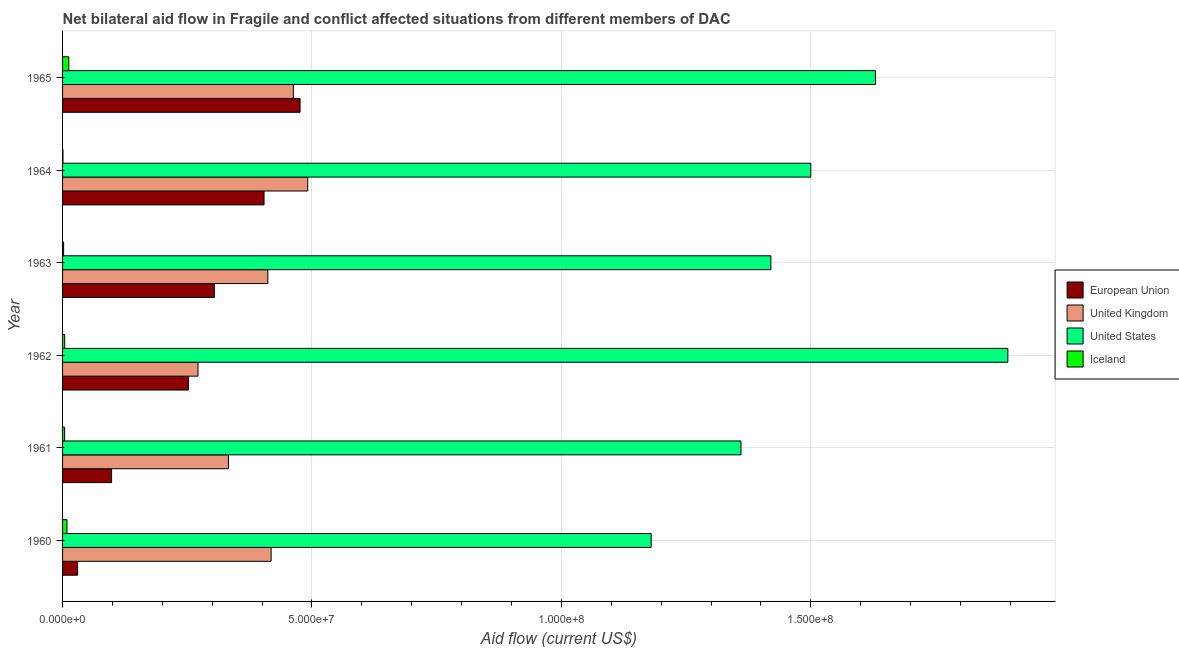Are the number of bars per tick equal to the number of legend labels?
Ensure brevity in your answer.  Yes. How many bars are there on the 1st tick from the bottom?
Offer a very short reply. 4. What is the label of the 5th group of bars from the top?
Give a very brief answer. 1961. What is the amount of aid given by us in 1962?
Offer a terse response. 1.90e+08. Across all years, what is the maximum amount of aid given by us?
Provide a short and direct response. 1.90e+08. Across all years, what is the minimum amount of aid given by iceland?
Provide a short and direct response. 8.00e+04. In which year was the amount of aid given by iceland maximum?
Provide a short and direct response. 1965. In which year was the amount of aid given by iceland minimum?
Provide a succinct answer. 1964. What is the total amount of aid given by us in the graph?
Your response must be concise. 8.98e+08. What is the difference between the amount of aid given by uk in 1963 and that in 1965?
Your answer should be compact. -5.11e+06. What is the difference between the amount of aid given by iceland in 1964 and the amount of aid given by us in 1960?
Your answer should be compact. -1.18e+08. What is the average amount of aid given by eu per year?
Your answer should be compact. 2.61e+07. In the year 1960, what is the difference between the amount of aid given by uk and amount of aid given by eu?
Give a very brief answer. 3.88e+07. In how many years, is the amount of aid given by uk greater than 20000000 US$?
Your answer should be compact. 6. What is the ratio of the amount of aid given by iceland in 1961 to that in 1964?
Give a very brief answer. 5.25. Is the amount of aid given by iceland in 1961 less than that in 1964?
Provide a succinct answer. No. Is the difference between the amount of aid given by eu in 1962 and 1964 greater than the difference between the amount of aid given by iceland in 1962 and 1964?
Ensure brevity in your answer.  No. What is the difference between the highest and the second highest amount of aid given by iceland?
Your answer should be compact. 3.70e+05. What is the difference between the highest and the lowest amount of aid given by uk?
Offer a terse response. 2.20e+07. Is the sum of the amount of aid given by uk in 1961 and 1965 greater than the maximum amount of aid given by eu across all years?
Provide a short and direct response. Yes. What does the 1st bar from the bottom in 1963 represents?
Give a very brief answer. European Union. How many bars are there?
Your answer should be compact. 24. How many years are there in the graph?
Keep it short and to the point. 6. What is the difference between two consecutive major ticks on the X-axis?
Ensure brevity in your answer.  5.00e+07. Are the values on the major ticks of X-axis written in scientific E-notation?
Provide a short and direct response. Yes. How many legend labels are there?
Keep it short and to the point. 4. How are the legend labels stacked?
Keep it short and to the point. Vertical. What is the title of the graph?
Your answer should be very brief. Net bilateral aid flow in Fragile and conflict affected situations from different members of DAC. What is the label or title of the X-axis?
Your response must be concise. Aid flow (current US$). What is the Aid flow (current US$) of European Union in 1960?
Provide a short and direct response. 3.02e+06. What is the Aid flow (current US$) of United Kingdom in 1960?
Provide a short and direct response. 4.18e+07. What is the Aid flow (current US$) in United States in 1960?
Offer a very short reply. 1.18e+08. What is the Aid flow (current US$) of Iceland in 1960?
Your answer should be very brief. 8.80e+05. What is the Aid flow (current US$) of European Union in 1961?
Your answer should be very brief. 9.83e+06. What is the Aid flow (current US$) in United Kingdom in 1961?
Your answer should be very brief. 3.33e+07. What is the Aid flow (current US$) of United States in 1961?
Make the answer very short. 1.36e+08. What is the Aid flow (current US$) of Iceland in 1961?
Your answer should be very brief. 4.20e+05. What is the Aid flow (current US$) in European Union in 1962?
Give a very brief answer. 2.52e+07. What is the Aid flow (current US$) of United Kingdom in 1962?
Offer a very short reply. 2.72e+07. What is the Aid flow (current US$) of United States in 1962?
Your response must be concise. 1.90e+08. What is the Aid flow (current US$) of Iceland in 1962?
Make the answer very short. 4.30e+05. What is the Aid flow (current US$) of European Union in 1963?
Your answer should be very brief. 3.04e+07. What is the Aid flow (current US$) of United Kingdom in 1963?
Provide a short and direct response. 4.12e+07. What is the Aid flow (current US$) in United States in 1963?
Your answer should be compact. 1.42e+08. What is the Aid flow (current US$) of European Union in 1964?
Give a very brief answer. 4.04e+07. What is the Aid flow (current US$) in United Kingdom in 1964?
Keep it short and to the point. 4.92e+07. What is the Aid flow (current US$) in United States in 1964?
Provide a succinct answer. 1.50e+08. What is the Aid flow (current US$) in European Union in 1965?
Your answer should be very brief. 4.76e+07. What is the Aid flow (current US$) of United Kingdom in 1965?
Your answer should be compact. 4.63e+07. What is the Aid flow (current US$) in United States in 1965?
Ensure brevity in your answer.  1.63e+08. What is the Aid flow (current US$) in Iceland in 1965?
Offer a very short reply. 1.25e+06. Across all years, what is the maximum Aid flow (current US$) of European Union?
Offer a very short reply. 4.76e+07. Across all years, what is the maximum Aid flow (current US$) of United Kingdom?
Your answer should be very brief. 4.92e+07. Across all years, what is the maximum Aid flow (current US$) of United States?
Offer a very short reply. 1.90e+08. Across all years, what is the maximum Aid flow (current US$) in Iceland?
Make the answer very short. 1.25e+06. Across all years, what is the minimum Aid flow (current US$) in European Union?
Make the answer very short. 3.02e+06. Across all years, what is the minimum Aid flow (current US$) in United Kingdom?
Your answer should be very brief. 2.72e+07. Across all years, what is the minimum Aid flow (current US$) of United States?
Offer a very short reply. 1.18e+08. Across all years, what is the minimum Aid flow (current US$) in Iceland?
Your answer should be compact. 8.00e+04. What is the total Aid flow (current US$) in European Union in the graph?
Provide a succinct answer. 1.56e+08. What is the total Aid flow (current US$) in United Kingdom in the graph?
Your answer should be compact. 2.39e+08. What is the total Aid flow (current US$) in United States in the graph?
Keep it short and to the point. 8.98e+08. What is the total Aid flow (current US$) of Iceland in the graph?
Provide a short and direct response. 3.27e+06. What is the difference between the Aid flow (current US$) of European Union in 1960 and that in 1961?
Give a very brief answer. -6.81e+06. What is the difference between the Aid flow (current US$) in United Kingdom in 1960 and that in 1961?
Your answer should be very brief. 8.55e+06. What is the difference between the Aid flow (current US$) of United States in 1960 and that in 1961?
Give a very brief answer. -1.80e+07. What is the difference between the Aid flow (current US$) in European Union in 1960 and that in 1962?
Ensure brevity in your answer.  -2.22e+07. What is the difference between the Aid flow (current US$) of United Kingdom in 1960 and that in 1962?
Ensure brevity in your answer.  1.47e+07. What is the difference between the Aid flow (current US$) in United States in 1960 and that in 1962?
Keep it short and to the point. -7.15e+07. What is the difference between the Aid flow (current US$) of Iceland in 1960 and that in 1962?
Ensure brevity in your answer.  4.50e+05. What is the difference between the Aid flow (current US$) in European Union in 1960 and that in 1963?
Offer a terse response. -2.74e+07. What is the difference between the Aid flow (current US$) of United Kingdom in 1960 and that in 1963?
Keep it short and to the point. 6.60e+05. What is the difference between the Aid flow (current US$) of United States in 1960 and that in 1963?
Offer a very short reply. -2.40e+07. What is the difference between the Aid flow (current US$) in Iceland in 1960 and that in 1963?
Make the answer very short. 6.70e+05. What is the difference between the Aid flow (current US$) in European Union in 1960 and that in 1964?
Your answer should be very brief. -3.74e+07. What is the difference between the Aid flow (current US$) in United Kingdom in 1960 and that in 1964?
Provide a succinct answer. -7.34e+06. What is the difference between the Aid flow (current US$) in United States in 1960 and that in 1964?
Ensure brevity in your answer.  -3.20e+07. What is the difference between the Aid flow (current US$) in European Union in 1960 and that in 1965?
Keep it short and to the point. -4.46e+07. What is the difference between the Aid flow (current US$) in United Kingdom in 1960 and that in 1965?
Your answer should be compact. -4.45e+06. What is the difference between the Aid flow (current US$) in United States in 1960 and that in 1965?
Your response must be concise. -4.50e+07. What is the difference between the Aid flow (current US$) of Iceland in 1960 and that in 1965?
Offer a very short reply. -3.70e+05. What is the difference between the Aid flow (current US$) in European Union in 1961 and that in 1962?
Provide a short and direct response. -1.54e+07. What is the difference between the Aid flow (current US$) in United Kingdom in 1961 and that in 1962?
Offer a terse response. 6.11e+06. What is the difference between the Aid flow (current US$) of United States in 1961 and that in 1962?
Ensure brevity in your answer.  -5.35e+07. What is the difference between the Aid flow (current US$) of Iceland in 1961 and that in 1962?
Keep it short and to the point. -10000. What is the difference between the Aid flow (current US$) of European Union in 1961 and that in 1963?
Offer a terse response. -2.06e+07. What is the difference between the Aid flow (current US$) in United Kingdom in 1961 and that in 1963?
Offer a very short reply. -7.89e+06. What is the difference between the Aid flow (current US$) of United States in 1961 and that in 1963?
Keep it short and to the point. -6.00e+06. What is the difference between the Aid flow (current US$) of Iceland in 1961 and that in 1963?
Your response must be concise. 2.10e+05. What is the difference between the Aid flow (current US$) of European Union in 1961 and that in 1964?
Offer a terse response. -3.06e+07. What is the difference between the Aid flow (current US$) in United Kingdom in 1961 and that in 1964?
Your answer should be compact. -1.59e+07. What is the difference between the Aid flow (current US$) of United States in 1961 and that in 1964?
Offer a very short reply. -1.40e+07. What is the difference between the Aid flow (current US$) of European Union in 1961 and that in 1965?
Provide a short and direct response. -3.78e+07. What is the difference between the Aid flow (current US$) in United Kingdom in 1961 and that in 1965?
Offer a terse response. -1.30e+07. What is the difference between the Aid flow (current US$) of United States in 1961 and that in 1965?
Your answer should be compact. -2.70e+07. What is the difference between the Aid flow (current US$) of Iceland in 1961 and that in 1965?
Offer a terse response. -8.30e+05. What is the difference between the Aid flow (current US$) of European Union in 1962 and that in 1963?
Keep it short and to the point. -5.21e+06. What is the difference between the Aid flow (current US$) in United Kingdom in 1962 and that in 1963?
Keep it short and to the point. -1.40e+07. What is the difference between the Aid flow (current US$) of United States in 1962 and that in 1963?
Provide a short and direct response. 4.75e+07. What is the difference between the Aid flow (current US$) in Iceland in 1962 and that in 1963?
Your answer should be compact. 2.20e+05. What is the difference between the Aid flow (current US$) of European Union in 1962 and that in 1964?
Your answer should be compact. -1.52e+07. What is the difference between the Aid flow (current US$) in United Kingdom in 1962 and that in 1964?
Provide a short and direct response. -2.20e+07. What is the difference between the Aid flow (current US$) in United States in 1962 and that in 1964?
Your answer should be very brief. 3.95e+07. What is the difference between the Aid flow (current US$) in Iceland in 1962 and that in 1964?
Your answer should be compact. 3.50e+05. What is the difference between the Aid flow (current US$) in European Union in 1962 and that in 1965?
Your answer should be compact. -2.24e+07. What is the difference between the Aid flow (current US$) in United Kingdom in 1962 and that in 1965?
Ensure brevity in your answer.  -1.91e+07. What is the difference between the Aid flow (current US$) in United States in 1962 and that in 1965?
Ensure brevity in your answer.  2.65e+07. What is the difference between the Aid flow (current US$) in Iceland in 1962 and that in 1965?
Provide a succinct answer. -8.20e+05. What is the difference between the Aid flow (current US$) of European Union in 1963 and that in 1964?
Keep it short and to the point. -9.96e+06. What is the difference between the Aid flow (current US$) of United Kingdom in 1963 and that in 1964?
Give a very brief answer. -8.00e+06. What is the difference between the Aid flow (current US$) in United States in 1963 and that in 1964?
Offer a very short reply. -8.00e+06. What is the difference between the Aid flow (current US$) in European Union in 1963 and that in 1965?
Your response must be concise. -1.72e+07. What is the difference between the Aid flow (current US$) in United Kingdom in 1963 and that in 1965?
Give a very brief answer. -5.11e+06. What is the difference between the Aid flow (current US$) of United States in 1963 and that in 1965?
Keep it short and to the point. -2.10e+07. What is the difference between the Aid flow (current US$) of Iceland in 1963 and that in 1965?
Offer a very short reply. -1.04e+06. What is the difference between the Aid flow (current US$) of European Union in 1964 and that in 1965?
Make the answer very short. -7.22e+06. What is the difference between the Aid flow (current US$) in United Kingdom in 1964 and that in 1965?
Make the answer very short. 2.89e+06. What is the difference between the Aid flow (current US$) in United States in 1964 and that in 1965?
Offer a terse response. -1.30e+07. What is the difference between the Aid flow (current US$) in Iceland in 1964 and that in 1965?
Ensure brevity in your answer.  -1.17e+06. What is the difference between the Aid flow (current US$) in European Union in 1960 and the Aid flow (current US$) in United Kingdom in 1961?
Your response must be concise. -3.02e+07. What is the difference between the Aid flow (current US$) of European Union in 1960 and the Aid flow (current US$) of United States in 1961?
Ensure brevity in your answer.  -1.33e+08. What is the difference between the Aid flow (current US$) in European Union in 1960 and the Aid flow (current US$) in Iceland in 1961?
Your answer should be very brief. 2.60e+06. What is the difference between the Aid flow (current US$) of United Kingdom in 1960 and the Aid flow (current US$) of United States in 1961?
Keep it short and to the point. -9.42e+07. What is the difference between the Aid flow (current US$) of United Kingdom in 1960 and the Aid flow (current US$) of Iceland in 1961?
Provide a short and direct response. 4.14e+07. What is the difference between the Aid flow (current US$) in United States in 1960 and the Aid flow (current US$) in Iceland in 1961?
Your response must be concise. 1.18e+08. What is the difference between the Aid flow (current US$) in European Union in 1960 and the Aid flow (current US$) in United Kingdom in 1962?
Provide a succinct answer. -2.41e+07. What is the difference between the Aid flow (current US$) of European Union in 1960 and the Aid flow (current US$) of United States in 1962?
Make the answer very short. -1.86e+08. What is the difference between the Aid flow (current US$) of European Union in 1960 and the Aid flow (current US$) of Iceland in 1962?
Keep it short and to the point. 2.59e+06. What is the difference between the Aid flow (current US$) in United Kingdom in 1960 and the Aid flow (current US$) in United States in 1962?
Your answer should be very brief. -1.48e+08. What is the difference between the Aid flow (current US$) in United Kingdom in 1960 and the Aid flow (current US$) in Iceland in 1962?
Offer a very short reply. 4.14e+07. What is the difference between the Aid flow (current US$) in United States in 1960 and the Aid flow (current US$) in Iceland in 1962?
Your response must be concise. 1.18e+08. What is the difference between the Aid flow (current US$) of European Union in 1960 and the Aid flow (current US$) of United Kingdom in 1963?
Your response must be concise. -3.81e+07. What is the difference between the Aid flow (current US$) in European Union in 1960 and the Aid flow (current US$) in United States in 1963?
Give a very brief answer. -1.39e+08. What is the difference between the Aid flow (current US$) of European Union in 1960 and the Aid flow (current US$) of Iceland in 1963?
Your answer should be very brief. 2.81e+06. What is the difference between the Aid flow (current US$) of United Kingdom in 1960 and the Aid flow (current US$) of United States in 1963?
Your answer should be compact. -1.00e+08. What is the difference between the Aid flow (current US$) of United Kingdom in 1960 and the Aid flow (current US$) of Iceland in 1963?
Offer a terse response. 4.16e+07. What is the difference between the Aid flow (current US$) of United States in 1960 and the Aid flow (current US$) of Iceland in 1963?
Offer a terse response. 1.18e+08. What is the difference between the Aid flow (current US$) of European Union in 1960 and the Aid flow (current US$) of United Kingdom in 1964?
Provide a succinct answer. -4.61e+07. What is the difference between the Aid flow (current US$) in European Union in 1960 and the Aid flow (current US$) in United States in 1964?
Offer a very short reply. -1.47e+08. What is the difference between the Aid flow (current US$) of European Union in 1960 and the Aid flow (current US$) of Iceland in 1964?
Offer a terse response. 2.94e+06. What is the difference between the Aid flow (current US$) of United Kingdom in 1960 and the Aid flow (current US$) of United States in 1964?
Your answer should be compact. -1.08e+08. What is the difference between the Aid flow (current US$) in United Kingdom in 1960 and the Aid flow (current US$) in Iceland in 1964?
Offer a very short reply. 4.17e+07. What is the difference between the Aid flow (current US$) of United States in 1960 and the Aid flow (current US$) of Iceland in 1964?
Keep it short and to the point. 1.18e+08. What is the difference between the Aid flow (current US$) of European Union in 1960 and the Aid flow (current US$) of United Kingdom in 1965?
Give a very brief answer. -4.32e+07. What is the difference between the Aid flow (current US$) of European Union in 1960 and the Aid flow (current US$) of United States in 1965?
Your answer should be compact. -1.60e+08. What is the difference between the Aid flow (current US$) in European Union in 1960 and the Aid flow (current US$) in Iceland in 1965?
Ensure brevity in your answer.  1.77e+06. What is the difference between the Aid flow (current US$) of United Kingdom in 1960 and the Aid flow (current US$) of United States in 1965?
Keep it short and to the point. -1.21e+08. What is the difference between the Aid flow (current US$) in United Kingdom in 1960 and the Aid flow (current US$) in Iceland in 1965?
Ensure brevity in your answer.  4.06e+07. What is the difference between the Aid flow (current US$) of United States in 1960 and the Aid flow (current US$) of Iceland in 1965?
Provide a succinct answer. 1.17e+08. What is the difference between the Aid flow (current US$) of European Union in 1961 and the Aid flow (current US$) of United Kingdom in 1962?
Provide a succinct answer. -1.73e+07. What is the difference between the Aid flow (current US$) of European Union in 1961 and the Aid flow (current US$) of United States in 1962?
Your answer should be compact. -1.80e+08. What is the difference between the Aid flow (current US$) of European Union in 1961 and the Aid flow (current US$) of Iceland in 1962?
Provide a succinct answer. 9.40e+06. What is the difference between the Aid flow (current US$) of United Kingdom in 1961 and the Aid flow (current US$) of United States in 1962?
Give a very brief answer. -1.56e+08. What is the difference between the Aid flow (current US$) in United Kingdom in 1961 and the Aid flow (current US$) in Iceland in 1962?
Offer a terse response. 3.28e+07. What is the difference between the Aid flow (current US$) of United States in 1961 and the Aid flow (current US$) of Iceland in 1962?
Your response must be concise. 1.36e+08. What is the difference between the Aid flow (current US$) of European Union in 1961 and the Aid flow (current US$) of United Kingdom in 1963?
Offer a very short reply. -3.13e+07. What is the difference between the Aid flow (current US$) in European Union in 1961 and the Aid flow (current US$) in United States in 1963?
Keep it short and to the point. -1.32e+08. What is the difference between the Aid flow (current US$) in European Union in 1961 and the Aid flow (current US$) in Iceland in 1963?
Make the answer very short. 9.62e+06. What is the difference between the Aid flow (current US$) in United Kingdom in 1961 and the Aid flow (current US$) in United States in 1963?
Your response must be concise. -1.09e+08. What is the difference between the Aid flow (current US$) of United Kingdom in 1961 and the Aid flow (current US$) of Iceland in 1963?
Provide a succinct answer. 3.30e+07. What is the difference between the Aid flow (current US$) of United States in 1961 and the Aid flow (current US$) of Iceland in 1963?
Offer a very short reply. 1.36e+08. What is the difference between the Aid flow (current US$) in European Union in 1961 and the Aid flow (current US$) in United Kingdom in 1964?
Your answer should be very brief. -3.93e+07. What is the difference between the Aid flow (current US$) of European Union in 1961 and the Aid flow (current US$) of United States in 1964?
Your answer should be very brief. -1.40e+08. What is the difference between the Aid flow (current US$) of European Union in 1961 and the Aid flow (current US$) of Iceland in 1964?
Offer a terse response. 9.75e+06. What is the difference between the Aid flow (current US$) in United Kingdom in 1961 and the Aid flow (current US$) in United States in 1964?
Provide a short and direct response. -1.17e+08. What is the difference between the Aid flow (current US$) in United Kingdom in 1961 and the Aid flow (current US$) in Iceland in 1964?
Ensure brevity in your answer.  3.32e+07. What is the difference between the Aid flow (current US$) of United States in 1961 and the Aid flow (current US$) of Iceland in 1964?
Offer a very short reply. 1.36e+08. What is the difference between the Aid flow (current US$) of European Union in 1961 and the Aid flow (current US$) of United Kingdom in 1965?
Keep it short and to the point. -3.64e+07. What is the difference between the Aid flow (current US$) in European Union in 1961 and the Aid flow (current US$) in United States in 1965?
Ensure brevity in your answer.  -1.53e+08. What is the difference between the Aid flow (current US$) in European Union in 1961 and the Aid flow (current US$) in Iceland in 1965?
Your answer should be very brief. 8.58e+06. What is the difference between the Aid flow (current US$) of United Kingdom in 1961 and the Aid flow (current US$) of United States in 1965?
Offer a very short reply. -1.30e+08. What is the difference between the Aid flow (current US$) in United Kingdom in 1961 and the Aid flow (current US$) in Iceland in 1965?
Make the answer very short. 3.20e+07. What is the difference between the Aid flow (current US$) in United States in 1961 and the Aid flow (current US$) in Iceland in 1965?
Make the answer very short. 1.35e+08. What is the difference between the Aid flow (current US$) of European Union in 1962 and the Aid flow (current US$) of United Kingdom in 1963?
Keep it short and to the point. -1.59e+07. What is the difference between the Aid flow (current US$) of European Union in 1962 and the Aid flow (current US$) of United States in 1963?
Your answer should be compact. -1.17e+08. What is the difference between the Aid flow (current US$) of European Union in 1962 and the Aid flow (current US$) of Iceland in 1963?
Provide a succinct answer. 2.50e+07. What is the difference between the Aid flow (current US$) in United Kingdom in 1962 and the Aid flow (current US$) in United States in 1963?
Your answer should be compact. -1.15e+08. What is the difference between the Aid flow (current US$) in United Kingdom in 1962 and the Aid flow (current US$) in Iceland in 1963?
Your response must be concise. 2.69e+07. What is the difference between the Aid flow (current US$) in United States in 1962 and the Aid flow (current US$) in Iceland in 1963?
Offer a very short reply. 1.89e+08. What is the difference between the Aid flow (current US$) in European Union in 1962 and the Aid flow (current US$) in United Kingdom in 1964?
Offer a terse response. -2.39e+07. What is the difference between the Aid flow (current US$) of European Union in 1962 and the Aid flow (current US$) of United States in 1964?
Keep it short and to the point. -1.25e+08. What is the difference between the Aid flow (current US$) in European Union in 1962 and the Aid flow (current US$) in Iceland in 1964?
Offer a very short reply. 2.51e+07. What is the difference between the Aid flow (current US$) of United Kingdom in 1962 and the Aid flow (current US$) of United States in 1964?
Your answer should be very brief. -1.23e+08. What is the difference between the Aid flow (current US$) in United Kingdom in 1962 and the Aid flow (current US$) in Iceland in 1964?
Offer a very short reply. 2.71e+07. What is the difference between the Aid flow (current US$) in United States in 1962 and the Aid flow (current US$) in Iceland in 1964?
Keep it short and to the point. 1.89e+08. What is the difference between the Aid flow (current US$) in European Union in 1962 and the Aid flow (current US$) in United Kingdom in 1965?
Offer a terse response. -2.10e+07. What is the difference between the Aid flow (current US$) of European Union in 1962 and the Aid flow (current US$) of United States in 1965?
Give a very brief answer. -1.38e+08. What is the difference between the Aid flow (current US$) of European Union in 1962 and the Aid flow (current US$) of Iceland in 1965?
Your answer should be very brief. 2.40e+07. What is the difference between the Aid flow (current US$) in United Kingdom in 1962 and the Aid flow (current US$) in United States in 1965?
Provide a short and direct response. -1.36e+08. What is the difference between the Aid flow (current US$) in United Kingdom in 1962 and the Aid flow (current US$) in Iceland in 1965?
Give a very brief answer. 2.59e+07. What is the difference between the Aid flow (current US$) in United States in 1962 and the Aid flow (current US$) in Iceland in 1965?
Make the answer very short. 1.88e+08. What is the difference between the Aid flow (current US$) in European Union in 1963 and the Aid flow (current US$) in United Kingdom in 1964?
Offer a terse response. -1.87e+07. What is the difference between the Aid flow (current US$) in European Union in 1963 and the Aid flow (current US$) in United States in 1964?
Your answer should be very brief. -1.20e+08. What is the difference between the Aid flow (current US$) of European Union in 1963 and the Aid flow (current US$) of Iceland in 1964?
Give a very brief answer. 3.04e+07. What is the difference between the Aid flow (current US$) of United Kingdom in 1963 and the Aid flow (current US$) of United States in 1964?
Give a very brief answer. -1.09e+08. What is the difference between the Aid flow (current US$) in United Kingdom in 1963 and the Aid flow (current US$) in Iceland in 1964?
Make the answer very short. 4.11e+07. What is the difference between the Aid flow (current US$) in United States in 1963 and the Aid flow (current US$) in Iceland in 1964?
Offer a very short reply. 1.42e+08. What is the difference between the Aid flow (current US$) in European Union in 1963 and the Aid flow (current US$) in United Kingdom in 1965?
Your response must be concise. -1.58e+07. What is the difference between the Aid flow (current US$) of European Union in 1963 and the Aid flow (current US$) of United States in 1965?
Your response must be concise. -1.33e+08. What is the difference between the Aid flow (current US$) in European Union in 1963 and the Aid flow (current US$) in Iceland in 1965?
Provide a succinct answer. 2.92e+07. What is the difference between the Aid flow (current US$) of United Kingdom in 1963 and the Aid flow (current US$) of United States in 1965?
Your answer should be compact. -1.22e+08. What is the difference between the Aid flow (current US$) of United Kingdom in 1963 and the Aid flow (current US$) of Iceland in 1965?
Offer a terse response. 3.99e+07. What is the difference between the Aid flow (current US$) of United States in 1963 and the Aid flow (current US$) of Iceland in 1965?
Make the answer very short. 1.41e+08. What is the difference between the Aid flow (current US$) in European Union in 1964 and the Aid flow (current US$) in United Kingdom in 1965?
Your response must be concise. -5.87e+06. What is the difference between the Aid flow (current US$) in European Union in 1964 and the Aid flow (current US$) in United States in 1965?
Give a very brief answer. -1.23e+08. What is the difference between the Aid flow (current US$) in European Union in 1964 and the Aid flow (current US$) in Iceland in 1965?
Keep it short and to the point. 3.91e+07. What is the difference between the Aid flow (current US$) of United Kingdom in 1964 and the Aid flow (current US$) of United States in 1965?
Your answer should be very brief. -1.14e+08. What is the difference between the Aid flow (current US$) of United Kingdom in 1964 and the Aid flow (current US$) of Iceland in 1965?
Provide a succinct answer. 4.79e+07. What is the difference between the Aid flow (current US$) in United States in 1964 and the Aid flow (current US$) in Iceland in 1965?
Ensure brevity in your answer.  1.49e+08. What is the average Aid flow (current US$) in European Union per year?
Keep it short and to the point. 2.61e+07. What is the average Aid flow (current US$) of United Kingdom per year?
Keep it short and to the point. 3.98e+07. What is the average Aid flow (current US$) of United States per year?
Provide a short and direct response. 1.50e+08. What is the average Aid flow (current US$) in Iceland per year?
Your answer should be compact. 5.45e+05. In the year 1960, what is the difference between the Aid flow (current US$) of European Union and Aid flow (current US$) of United Kingdom?
Offer a terse response. -3.88e+07. In the year 1960, what is the difference between the Aid flow (current US$) in European Union and Aid flow (current US$) in United States?
Offer a very short reply. -1.15e+08. In the year 1960, what is the difference between the Aid flow (current US$) in European Union and Aid flow (current US$) in Iceland?
Your answer should be very brief. 2.14e+06. In the year 1960, what is the difference between the Aid flow (current US$) of United Kingdom and Aid flow (current US$) of United States?
Keep it short and to the point. -7.62e+07. In the year 1960, what is the difference between the Aid flow (current US$) in United Kingdom and Aid flow (current US$) in Iceland?
Offer a very short reply. 4.09e+07. In the year 1960, what is the difference between the Aid flow (current US$) in United States and Aid flow (current US$) in Iceland?
Offer a terse response. 1.17e+08. In the year 1961, what is the difference between the Aid flow (current US$) of European Union and Aid flow (current US$) of United Kingdom?
Your answer should be compact. -2.34e+07. In the year 1961, what is the difference between the Aid flow (current US$) of European Union and Aid flow (current US$) of United States?
Offer a terse response. -1.26e+08. In the year 1961, what is the difference between the Aid flow (current US$) in European Union and Aid flow (current US$) in Iceland?
Keep it short and to the point. 9.41e+06. In the year 1961, what is the difference between the Aid flow (current US$) in United Kingdom and Aid flow (current US$) in United States?
Your answer should be very brief. -1.03e+08. In the year 1961, what is the difference between the Aid flow (current US$) of United Kingdom and Aid flow (current US$) of Iceland?
Give a very brief answer. 3.28e+07. In the year 1961, what is the difference between the Aid flow (current US$) of United States and Aid flow (current US$) of Iceland?
Your answer should be very brief. 1.36e+08. In the year 1962, what is the difference between the Aid flow (current US$) in European Union and Aid flow (current US$) in United Kingdom?
Offer a terse response. -1.93e+06. In the year 1962, what is the difference between the Aid flow (current US$) in European Union and Aid flow (current US$) in United States?
Provide a succinct answer. -1.64e+08. In the year 1962, what is the difference between the Aid flow (current US$) of European Union and Aid flow (current US$) of Iceland?
Ensure brevity in your answer.  2.48e+07. In the year 1962, what is the difference between the Aid flow (current US$) of United Kingdom and Aid flow (current US$) of United States?
Your response must be concise. -1.62e+08. In the year 1962, what is the difference between the Aid flow (current US$) of United Kingdom and Aid flow (current US$) of Iceland?
Give a very brief answer. 2.67e+07. In the year 1962, what is the difference between the Aid flow (current US$) in United States and Aid flow (current US$) in Iceland?
Offer a terse response. 1.89e+08. In the year 1963, what is the difference between the Aid flow (current US$) in European Union and Aid flow (current US$) in United Kingdom?
Make the answer very short. -1.07e+07. In the year 1963, what is the difference between the Aid flow (current US$) of European Union and Aid flow (current US$) of United States?
Your response must be concise. -1.12e+08. In the year 1963, what is the difference between the Aid flow (current US$) of European Union and Aid flow (current US$) of Iceland?
Provide a succinct answer. 3.02e+07. In the year 1963, what is the difference between the Aid flow (current US$) of United Kingdom and Aid flow (current US$) of United States?
Your answer should be very brief. -1.01e+08. In the year 1963, what is the difference between the Aid flow (current US$) in United Kingdom and Aid flow (current US$) in Iceland?
Your response must be concise. 4.09e+07. In the year 1963, what is the difference between the Aid flow (current US$) in United States and Aid flow (current US$) in Iceland?
Make the answer very short. 1.42e+08. In the year 1964, what is the difference between the Aid flow (current US$) of European Union and Aid flow (current US$) of United Kingdom?
Ensure brevity in your answer.  -8.76e+06. In the year 1964, what is the difference between the Aid flow (current US$) of European Union and Aid flow (current US$) of United States?
Offer a terse response. -1.10e+08. In the year 1964, what is the difference between the Aid flow (current US$) in European Union and Aid flow (current US$) in Iceland?
Provide a succinct answer. 4.03e+07. In the year 1964, what is the difference between the Aid flow (current US$) in United Kingdom and Aid flow (current US$) in United States?
Keep it short and to the point. -1.01e+08. In the year 1964, what is the difference between the Aid flow (current US$) in United Kingdom and Aid flow (current US$) in Iceland?
Ensure brevity in your answer.  4.91e+07. In the year 1964, what is the difference between the Aid flow (current US$) in United States and Aid flow (current US$) in Iceland?
Offer a very short reply. 1.50e+08. In the year 1965, what is the difference between the Aid flow (current US$) in European Union and Aid flow (current US$) in United Kingdom?
Your response must be concise. 1.35e+06. In the year 1965, what is the difference between the Aid flow (current US$) in European Union and Aid flow (current US$) in United States?
Give a very brief answer. -1.15e+08. In the year 1965, what is the difference between the Aid flow (current US$) in European Union and Aid flow (current US$) in Iceland?
Make the answer very short. 4.64e+07. In the year 1965, what is the difference between the Aid flow (current US$) of United Kingdom and Aid flow (current US$) of United States?
Ensure brevity in your answer.  -1.17e+08. In the year 1965, what is the difference between the Aid flow (current US$) of United Kingdom and Aid flow (current US$) of Iceland?
Offer a terse response. 4.50e+07. In the year 1965, what is the difference between the Aid flow (current US$) of United States and Aid flow (current US$) of Iceland?
Your response must be concise. 1.62e+08. What is the ratio of the Aid flow (current US$) in European Union in 1960 to that in 1961?
Make the answer very short. 0.31. What is the ratio of the Aid flow (current US$) in United Kingdom in 1960 to that in 1961?
Offer a terse response. 1.26. What is the ratio of the Aid flow (current US$) of United States in 1960 to that in 1961?
Offer a terse response. 0.87. What is the ratio of the Aid flow (current US$) in Iceland in 1960 to that in 1961?
Your response must be concise. 2.1. What is the ratio of the Aid flow (current US$) in European Union in 1960 to that in 1962?
Provide a short and direct response. 0.12. What is the ratio of the Aid flow (current US$) in United Kingdom in 1960 to that in 1962?
Provide a succinct answer. 1.54. What is the ratio of the Aid flow (current US$) of United States in 1960 to that in 1962?
Provide a succinct answer. 0.62. What is the ratio of the Aid flow (current US$) in Iceland in 1960 to that in 1962?
Ensure brevity in your answer.  2.05. What is the ratio of the Aid flow (current US$) of European Union in 1960 to that in 1963?
Your response must be concise. 0.1. What is the ratio of the Aid flow (current US$) in United States in 1960 to that in 1963?
Your answer should be compact. 0.83. What is the ratio of the Aid flow (current US$) in Iceland in 1960 to that in 1963?
Your answer should be very brief. 4.19. What is the ratio of the Aid flow (current US$) of European Union in 1960 to that in 1964?
Provide a short and direct response. 0.07. What is the ratio of the Aid flow (current US$) of United Kingdom in 1960 to that in 1964?
Provide a succinct answer. 0.85. What is the ratio of the Aid flow (current US$) of United States in 1960 to that in 1964?
Offer a terse response. 0.79. What is the ratio of the Aid flow (current US$) in Iceland in 1960 to that in 1964?
Your answer should be compact. 11. What is the ratio of the Aid flow (current US$) of European Union in 1960 to that in 1965?
Offer a terse response. 0.06. What is the ratio of the Aid flow (current US$) in United Kingdom in 1960 to that in 1965?
Keep it short and to the point. 0.9. What is the ratio of the Aid flow (current US$) of United States in 1960 to that in 1965?
Your answer should be compact. 0.72. What is the ratio of the Aid flow (current US$) in Iceland in 1960 to that in 1965?
Your answer should be very brief. 0.7. What is the ratio of the Aid flow (current US$) of European Union in 1961 to that in 1962?
Keep it short and to the point. 0.39. What is the ratio of the Aid flow (current US$) of United Kingdom in 1961 to that in 1962?
Make the answer very short. 1.23. What is the ratio of the Aid flow (current US$) in United States in 1961 to that in 1962?
Provide a succinct answer. 0.72. What is the ratio of the Aid flow (current US$) of Iceland in 1961 to that in 1962?
Your response must be concise. 0.98. What is the ratio of the Aid flow (current US$) of European Union in 1961 to that in 1963?
Ensure brevity in your answer.  0.32. What is the ratio of the Aid flow (current US$) in United Kingdom in 1961 to that in 1963?
Offer a very short reply. 0.81. What is the ratio of the Aid flow (current US$) of United States in 1961 to that in 1963?
Your response must be concise. 0.96. What is the ratio of the Aid flow (current US$) of European Union in 1961 to that in 1964?
Your answer should be compact. 0.24. What is the ratio of the Aid flow (current US$) of United Kingdom in 1961 to that in 1964?
Offer a very short reply. 0.68. What is the ratio of the Aid flow (current US$) in United States in 1961 to that in 1964?
Your answer should be compact. 0.91. What is the ratio of the Aid flow (current US$) in Iceland in 1961 to that in 1964?
Provide a succinct answer. 5.25. What is the ratio of the Aid flow (current US$) of European Union in 1961 to that in 1965?
Offer a terse response. 0.21. What is the ratio of the Aid flow (current US$) of United Kingdom in 1961 to that in 1965?
Provide a short and direct response. 0.72. What is the ratio of the Aid flow (current US$) in United States in 1961 to that in 1965?
Your answer should be very brief. 0.83. What is the ratio of the Aid flow (current US$) in Iceland in 1961 to that in 1965?
Keep it short and to the point. 0.34. What is the ratio of the Aid flow (current US$) of European Union in 1962 to that in 1963?
Ensure brevity in your answer.  0.83. What is the ratio of the Aid flow (current US$) in United Kingdom in 1962 to that in 1963?
Your response must be concise. 0.66. What is the ratio of the Aid flow (current US$) of United States in 1962 to that in 1963?
Offer a terse response. 1.33. What is the ratio of the Aid flow (current US$) in Iceland in 1962 to that in 1963?
Your answer should be very brief. 2.05. What is the ratio of the Aid flow (current US$) of European Union in 1962 to that in 1964?
Give a very brief answer. 0.62. What is the ratio of the Aid flow (current US$) of United Kingdom in 1962 to that in 1964?
Offer a very short reply. 0.55. What is the ratio of the Aid flow (current US$) of United States in 1962 to that in 1964?
Offer a very short reply. 1.26. What is the ratio of the Aid flow (current US$) in Iceland in 1962 to that in 1964?
Offer a terse response. 5.38. What is the ratio of the Aid flow (current US$) in European Union in 1962 to that in 1965?
Give a very brief answer. 0.53. What is the ratio of the Aid flow (current US$) in United Kingdom in 1962 to that in 1965?
Give a very brief answer. 0.59. What is the ratio of the Aid flow (current US$) in United States in 1962 to that in 1965?
Give a very brief answer. 1.16. What is the ratio of the Aid flow (current US$) of Iceland in 1962 to that in 1965?
Your response must be concise. 0.34. What is the ratio of the Aid flow (current US$) in European Union in 1963 to that in 1964?
Ensure brevity in your answer.  0.75. What is the ratio of the Aid flow (current US$) in United Kingdom in 1963 to that in 1964?
Your answer should be compact. 0.84. What is the ratio of the Aid flow (current US$) of United States in 1963 to that in 1964?
Make the answer very short. 0.95. What is the ratio of the Aid flow (current US$) of Iceland in 1963 to that in 1964?
Keep it short and to the point. 2.62. What is the ratio of the Aid flow (current US$) of European Union in 1963 to that in 1965?
Keep it short and to the point. 0.64. What is the ratio of the Aid flow (current US$) in United Kingdom in 1963 to that in 1965?
Make the answer very short. 0.89. What is the ratio of the Aid flow (current US$) in United States in 1963 to that in 1965?
Your answer should be very brief. 0.87. What is the ratio of the Aid flow (current US$) in Iceland in 1963 to that in 1965?
Make the answer very short. 0.17. What is the ratio of the Aid flow (current US$) of European Union in 1964 to that in 1965?
Provide a succinct answer. 0.85. What is the ratio of the Aid flow (current US$) of United Kingdom in 1964 to that in 1965?
Offer a very short reply. 1.06. What is the ratio of the Aid flow (current US$) of United States in 1964 to that in 1965?
Ensure brevity in your answer.  0.92. What is the ratio of the Aid flow (current US$) of Iceland in 1964 to that in 1965?
Keep it short and to the point. 0.06. What is the difference between the highest and the second highest Aid flow (current US$) of European Union?
Your answer should be very brief. 7.22e+06. What is the difference between the highest and the second highest Aid flow (current US$) of United Kingdom?
Your answer should be compact. 2.89e+06. What is the difference between the highest and the second highest Aid flow (current US$) in United States?
Provide a short and direct response. 2.65e+07. What is the difference between the highest and the second highest Aid flow (current US$) of Iceland?
Keep it short and to the point. 3.70e+05. What is the difference between the highest and the lowest Aid flow (current US$) of European Union?
Your answer should be compact. 4.46e+07. What is the difference between the highest and the lowest Aid flow (current US$) of United Kingdom?
Keep it short and to the point. 2.20e+07. What is the difference between the highest and the lowest Aid flow (current US$) in United States?
Offer a terse response. 7.15e+07. What is the difference between the highest and the lowest Aid flow (current US$) in Iceland?
Offer a very short reply. 1.17e+06. 